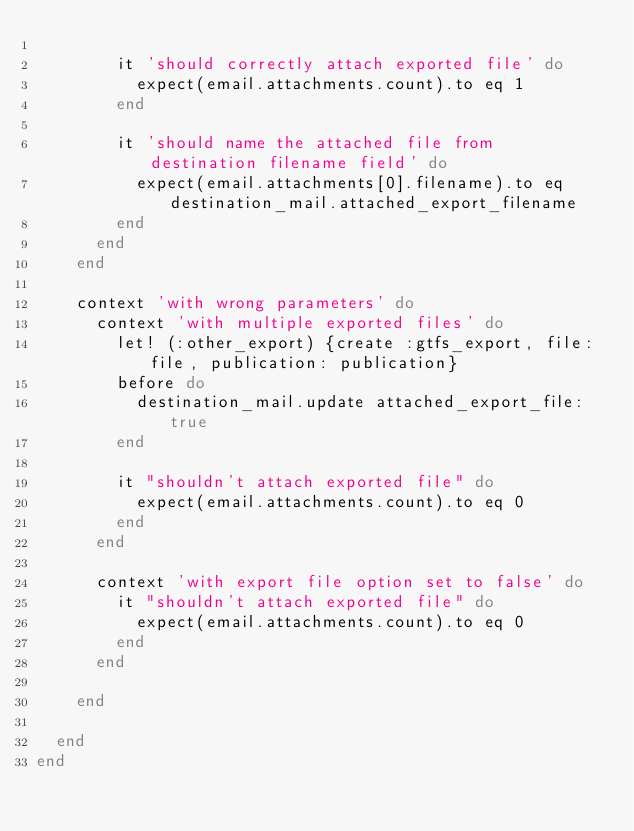<code> <loc_0><loc_0><loc_500><loc_500><_Ruby_>
        it 'should correctly attach exported file' do
          expect(email.attachments.count).to eq 1
        end

        it 'should name the attached file from destination filename field' do
          expect(email.attachments[0].filename).to eq destination_mail.attached_export_filename
        end
      end
    end

    context 'with wrong parameters' do
      context 'with multiple exported files' do
        let! (:other_export) {create :gtfs_export, file: file, publication: publication}
        before do
          destination_mail.update attached_export_file: true
        end

        it "shouldn't attach exported file" do
          expect(email.attachments.count).to eq 0
        end
      end

      context 'with export file option set to false' do
        it "shouldn't attach exported file" do
          expect(email.attachments.count).to eq 0
        end
      end

    end

  end
end
</code> 